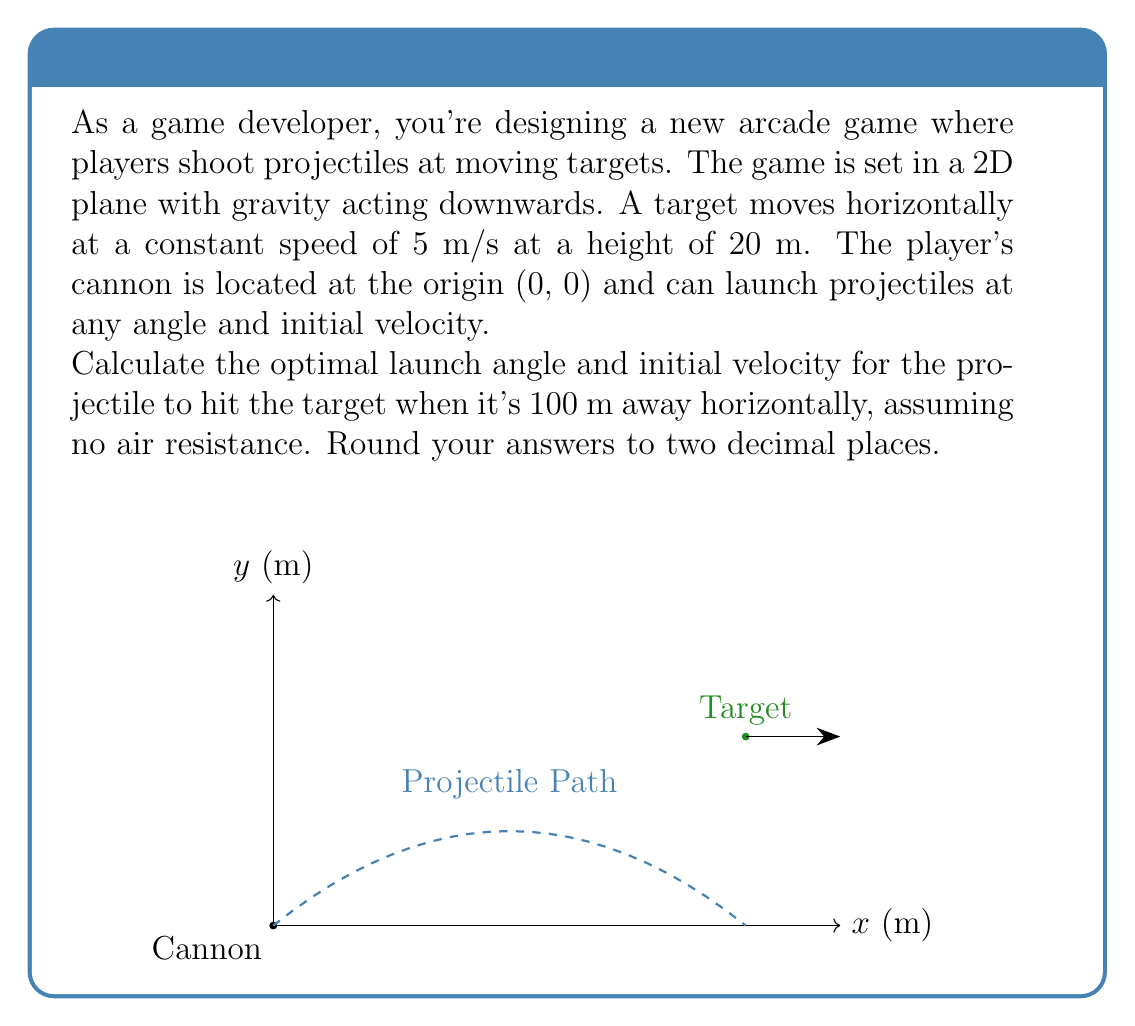Provide a solution to this math problem. Let's approach this step-by-step:

1) First, we need to use the equations of motion for a projectile. The horizontal and vertical positions after time $t$ are given by:

   $$x = v_0 \cos(\theta) t$$
   $$y = v_0 \sin(\theta) t - \frac{1}{2}gt^2$$

   Where $v_0$ is the initial velocity, $\theta$ is the launch angle, and $g$ is the acceleration due to gravity (9.8 m/s²).

2) We know that the target is at $x = 100$ m and $y = 20$ m when the projectile hits it. Let's call the time it takes for the projectile to reach the target $T$. We can write:

   $$100 = v_0 \cos(\theta) T$$
   $$20 = v_0 \sin(\theta) T - \frac{1}{2}g T^2$$

3) We also know that the target is moving at 5 m/s, so:

   $$T = \frac{100}{5} = 20\text{ s}$$

4) Substituting this into our first equation:

   $$100 = v_0 \cos(\theta) (20)$$
   $$v_0 \cos(\theta) = 5$$

5) And into our second equation:

   $$20 = v_0 \sin(\theta) (20) - \frac{1}{2}(9.8) (20)^2$$
   $$20 = 20v_0 \sin(\theta) - 1960$$
   $$v_0 \sin(\theta) = 99$$

6) Now we have two equations:

   $$v_0 \cos(\theta) = 5$$
   $$v_0 \sin(\theta) = 99$$

7) Dividing the second by the first:

   $$\tan(\theta) = \frac{99}{5} = 19.8$$

8) Therefore:

   $$\theta = \arctan(19.8) = 87.11°$$

9) We can find $v_0$ using either of the equations from step 6:

   $$v_0 = \frac{5}{\cos(87.11°)} = 99.12\text{ m/s}$$

10) Rounding to two decimal places:

    Optimal launch angle: 87.11°
    Initial velocity: 99.12 m/s
Answer: 87.11°, 99.12 m/s 